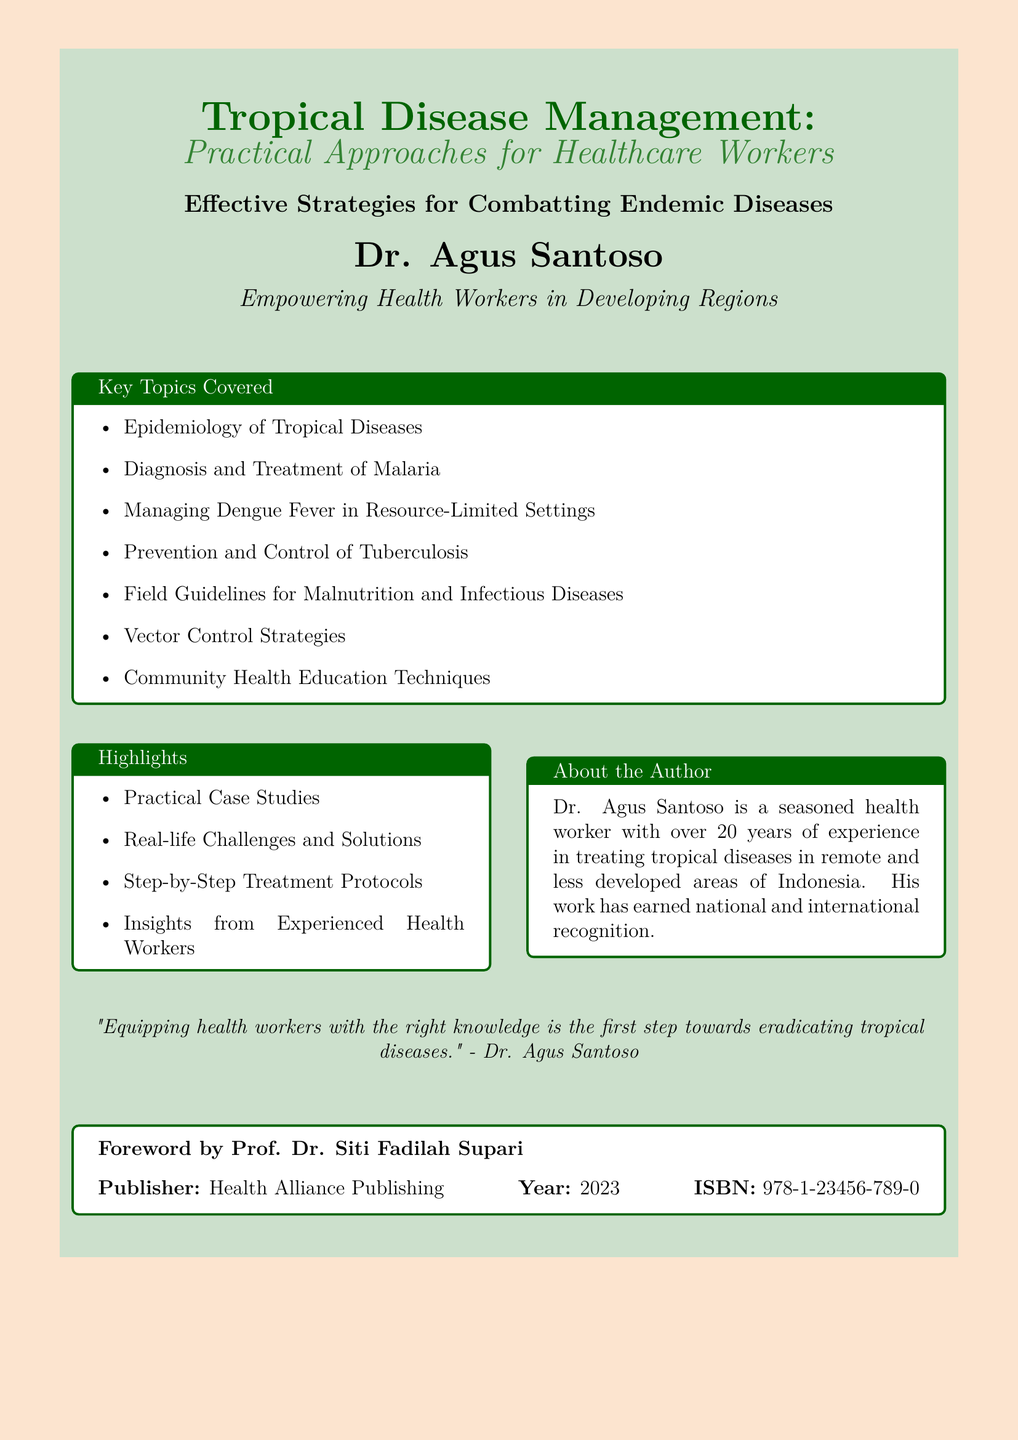what is the title of the book? The title is prominently displayed at the top of the document, indicating the main subject of the book.
Answer: Tropical Disease Management: Practical Approaches for Healthcare Workers who is the author of the book? The author's name is listed below the title, identifying the person responsible for the content of the book.
Answer: Dr. Agus Santoso what year was the book published? The publication year is stated towards the end of the document, indicating when the book was made available to the public.
Answer: 2023 what are the two key topics covered in the document? The key topics section lists several areas of focus in the book; two specific examples can be chosen from this list.
Answer: Epidemiology of Tropical Diseases, Vector Control Strategies how many years of experience does the author have? The author’s experience is mentioned in the description about him, indicating his expertise in the field.
Answer: 20 years what is one of the highlights mentioned in the document? The highlights section outlines important features of the book that appeal to readers, providing a glimpse into the content.
Answer: Practical Case Studies who wrote the foreword for the book? The foreword section specifies who provided an introduction to the book, a common practice in published works for endorsement.
Answer: Prof. Dr. Siti Fadilah Supari what is the main goal of the book according to the author? The author's quote at the end of the document summarizes his perspective on the importance of the information provided in the book.
Answer: Equipping health workers with the right knowledge 